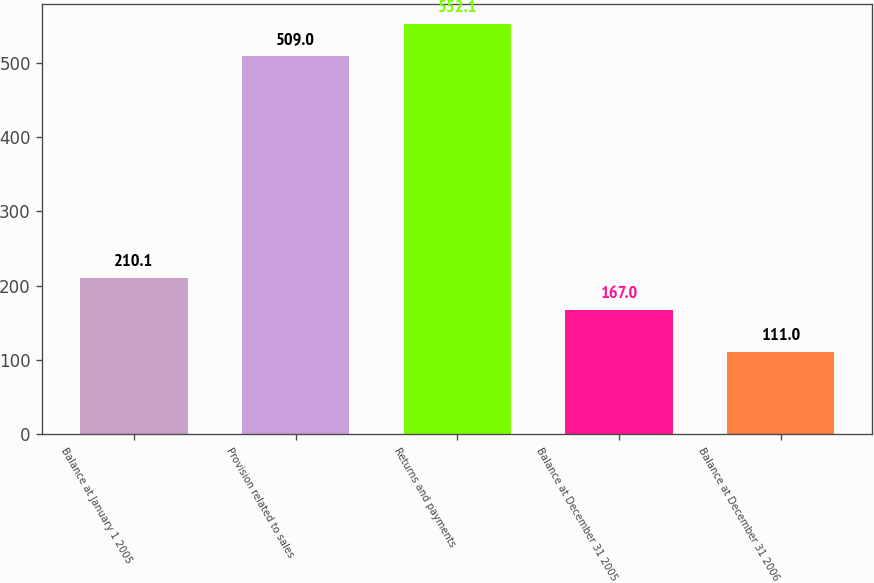Convert chart. <chart><loc_0><loc_0><loc_500><loc_500><bar_chart><fcel>Balance at January 1 2005<fcel>Provision related to sales<fcel>Returns and payments<fcel>Balance at December 31 2005<fcel>Balance at December 31 2006<nl><fcel>210.1<fcel>509<fcel>552.1<fcel>167<fcel>111<nl></chart> 